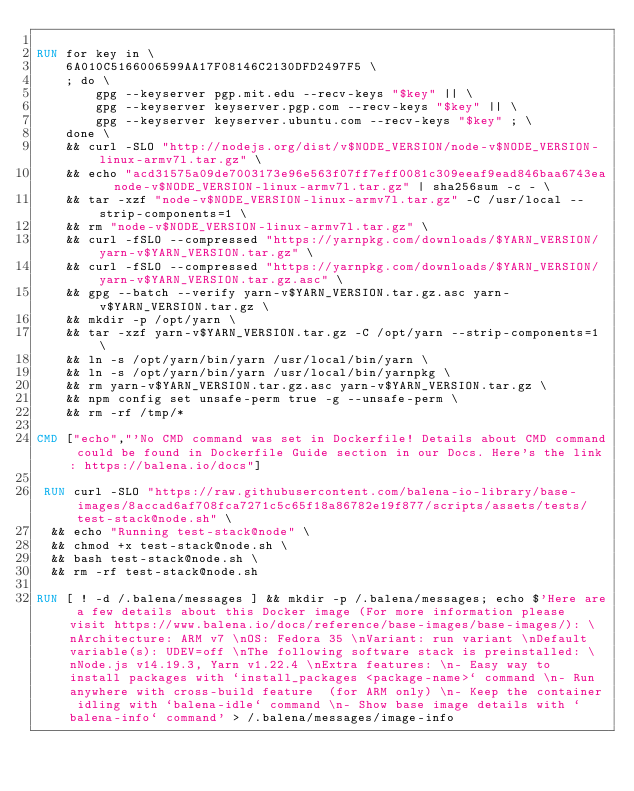<code> <loc_0><loc_0><loc_500><loc_500><_Dockerfile_>
RUN for key in \
	6A010C5166006599AA17F08146C2130DFD2497F5 \
	; do \
		gpg --keyserver pgp.mit.edu --recv-keys "$key" || \
		gpg --keyserver keyserver.pgp.com --recv-keys "$key" || \
		gpg --keyserver keyserver.ubuntu.com --recv-keys "$key" ; \
	done \
	&& curl -SLO "http://nodejs.org/dist/v$NODE_VERSION/node-v$NODE_VERSION-linux-armv7l.tar.gz" \
	&& echo "acd31575a09de7003173e96e563f07ff7eff0081c309eeaf9ead846baa6743ea  node-v$NODE_VERSION-linux-armv7l.tar.gz" | sha256sum -c - \
	&& tar -xzf "node-v$NODE_VERSION-linux-armv7l.tar.gz" -C /usr/local --strip-components=1 \
	&& rm "node-v$NODE_VERSION-linux-armv7l.tar.gz" \
	&& curl -fSLO --compressed "https://yarnpkg.com/downloads/$YARN_VERSION/yarn-v$YARN_VERSION.tar.gz" \
	&& curl -fSLO --compressed "https://yarnpkg.com/downloads/$YARN_VERSION/yarn-v$YARN_VERSION.tar.gz.asc" \
	&& gpg --batch --verify yarn-v$YARN_VERSION.tar.gz.asc yarn-v$YARN_VERSION.tar.gz \
	&& mkdir -p /opt/yarn \
	&& tar -xzf yarn-v$YARN_VERSION.tar.gz -C /opt/yarn --strip-components=1 \
	&& ln -s /opt/yarn/bin/yarn /usr/local/bin/yarn \
	&& ln -s /opt/yarn/bin/yarn /usr/local/bin/yarnpkg \
	&& rm yarn-v$YARN_VERSION.tar.gz.asc yarn-v$YARN_VERSION.tar.gz \
	&& npm config set unsafe-perm true -g --unsafe-perm \
	&& rm -rf /tmp/*

CMD ["echo","'No CMD command was set in Dockerfile! Details about CMD command could be found in Dockerfile Guide section in our Docs. Here's the link: https://balena.io/docs"]

 RUN curl -SLO "https://raw.githubusercontent.com/balena-io-library/base-images/8accad6af708fca7271c5c65f18a86782e19f877/scripts/assets/tests/test-stack@node.sh" \
  && echo "Running test-stack@node" \
  && chmod +x test-stack@node.sh \
  && bash test-stack@node.sh \
  && rm -rf test-stack@node.sh 

RUN [ ! -d /.balena/messages ] && mkdir -p /.balena/messages; echo $'Here are a few details about this Docker image (For more information please visit https://www.balena.io/docs/reference/base-images/base-images/): \nArchitecture: ARM v7 \nOS: Fedora 35 \nVariant: run variant \nDefault variable(s): UDEV=off \nThe following software stack is preinstalled: \nNode.js v14.19.3, Yarn v1.22.4 \nExtra features: \n- Easy way to install packages with `install_packages <package-name>` command \n- Run anywhere with cross-build feature  (for ARM only) \n- Keep the container idling with `balena-idle` command \n- Show base image details with `balena-info` command' > /.balena/messages/image-info</code> 